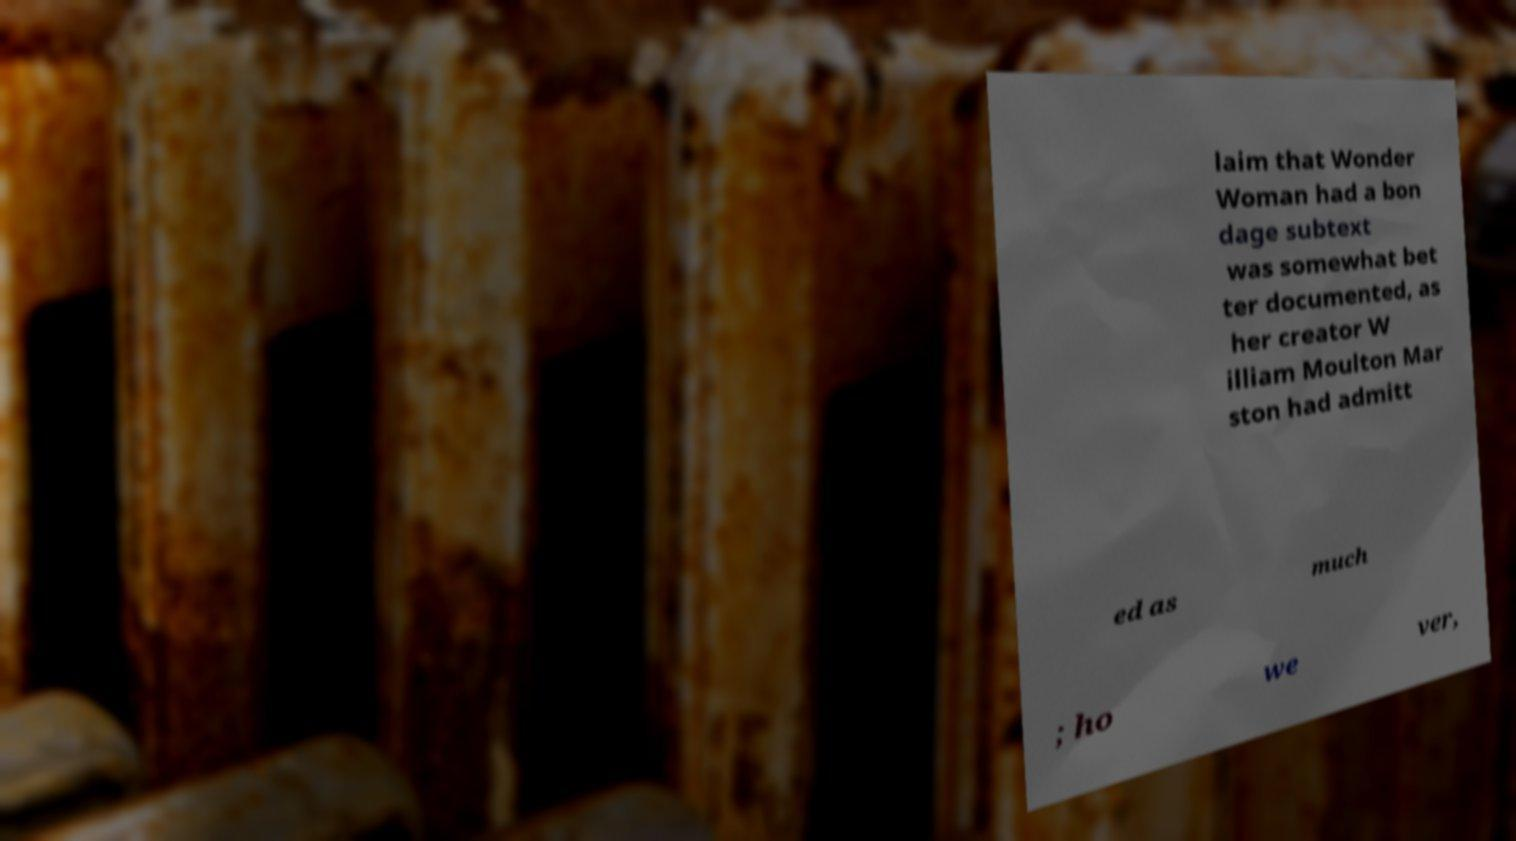There's text embedded in this image that I need extracted. Can you transcribe it verbatim? laim that Wonder Woman had a bon dage subtext was somewhat bet ter documented, as her creator W illiam Moulton Mar ston had admitt ed as much ; ho we ver, 